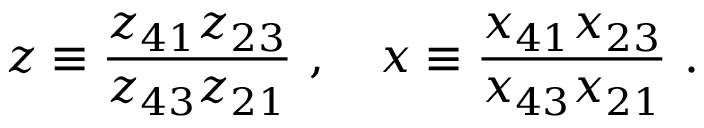<formula> <loc_0><loc_0><loc_500><loc_500>z \equiv \frac { z _ { 4 1 } z _ { 2 3 } } { z _ { 4 3 } z _ { 2 1 } } , x \equiv \frac { x _ { 4 1 } x _ { 2 3 } } { x _ { 4 3 } x _ { 2 1 } } .</formula> 